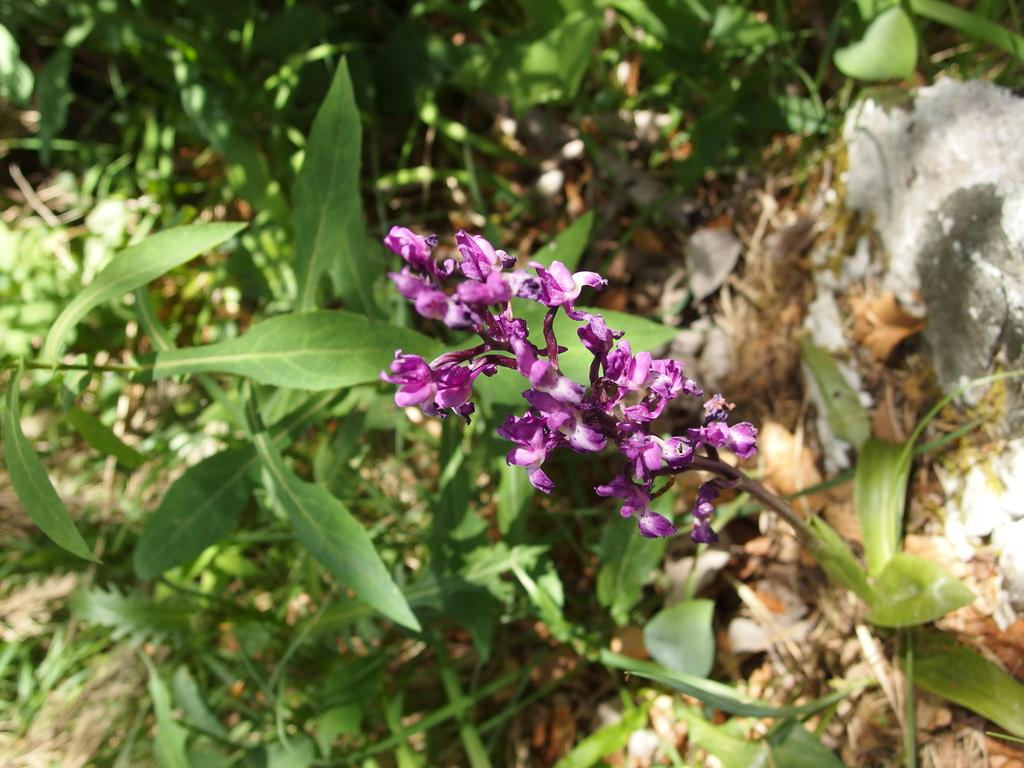What is present on the plant in the image? There is a bunch of flowers on the stem of a plant in the image. What else can be seen on the plant besides the flowers? There are leaves visible in the image. What type of fruit can be seen hanging from the plant in the image? There is no fruit present on the plant in the image; it only has flowers and leaves. 